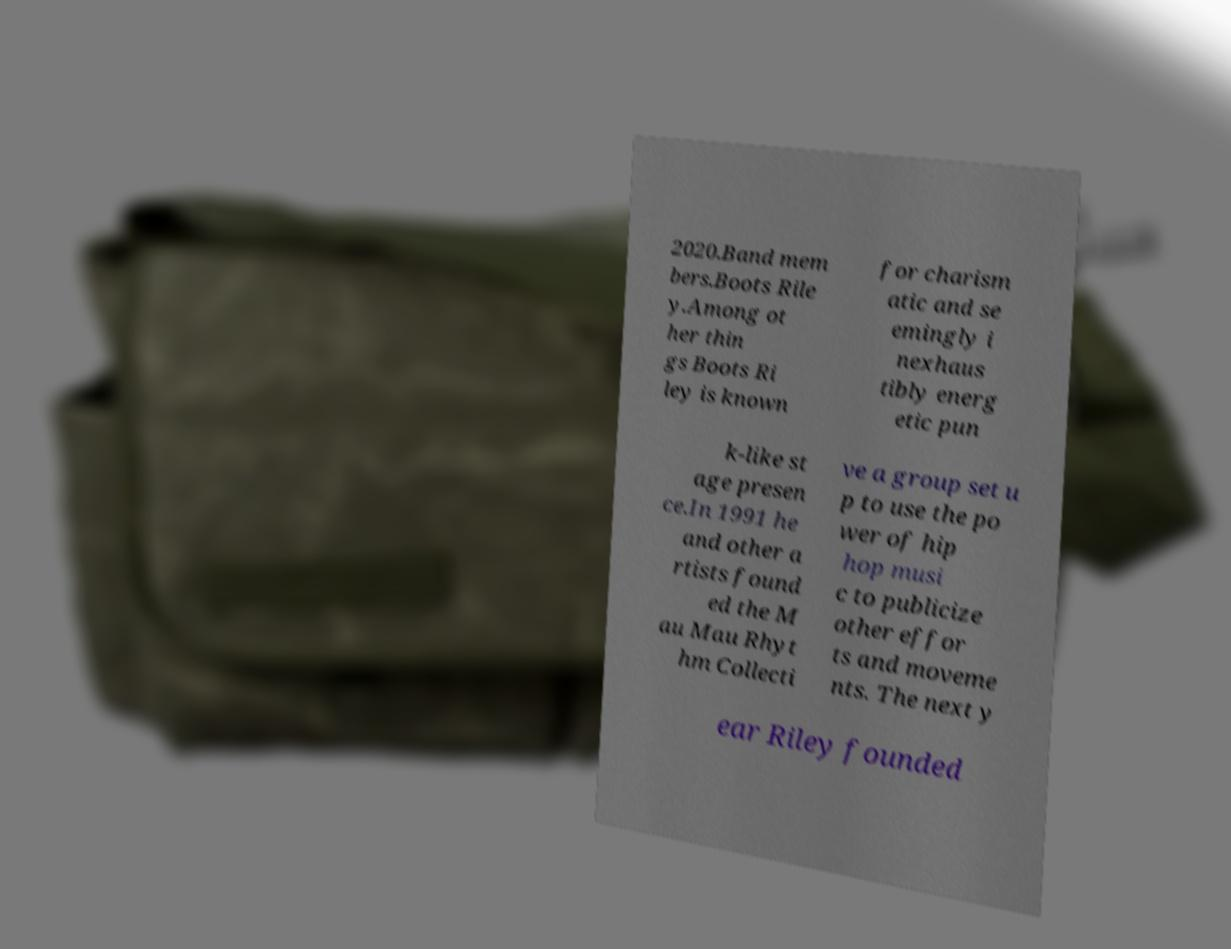For documentation purposes, I need the text within this image transcribed. Could you provide that? 2020.Band mem bers.Boots Rile y.Among ot her thin gs Boots Ri ley is known for charism atic and se emingly i nexhaus tibly energ etic pun k-like st age presen ce.In 1991 he and other a rtists found ed the M au Mau Rhyt hm Collecti ve a group set u p to use the po wer of hip hop musi c to publicize other effor ts and moveme nts. The next y ear Riley founded 